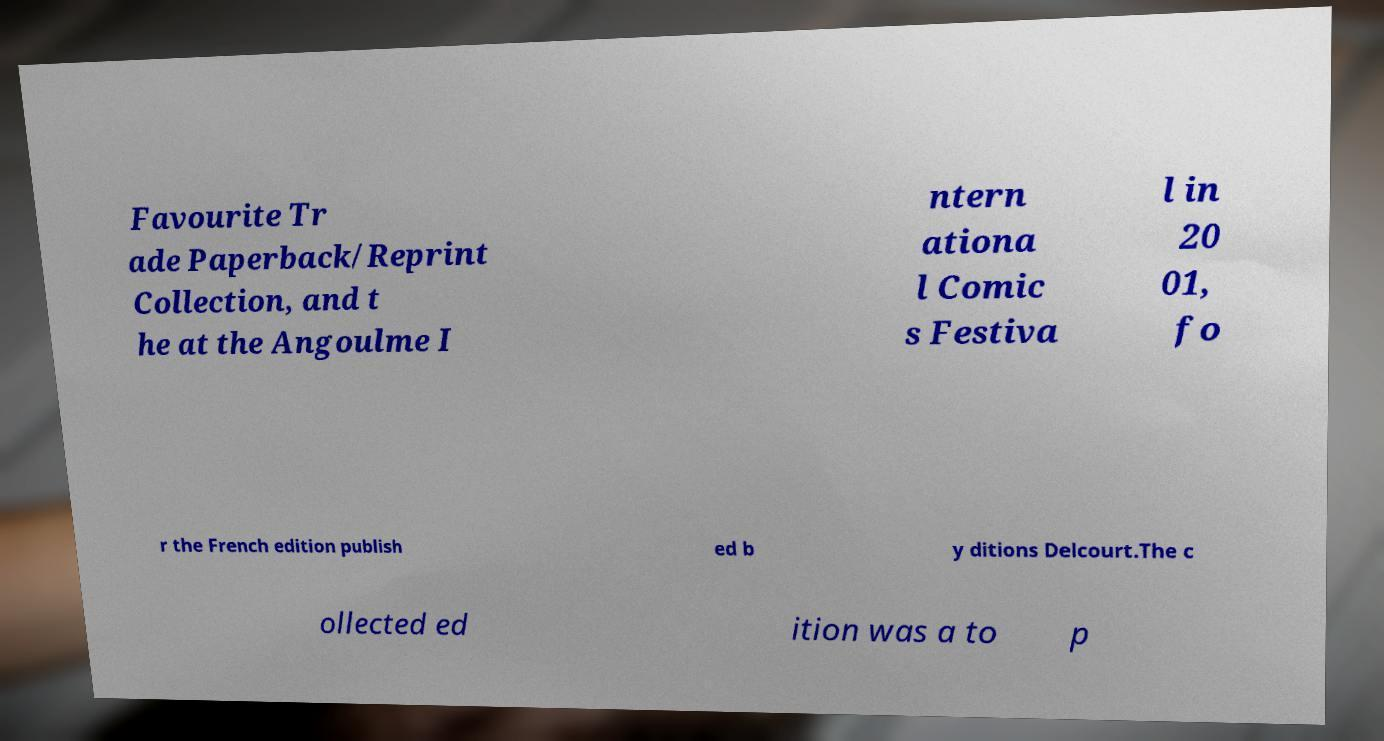There's text embedded in this image that I need extracted. Can you transcribe it verbatim? Favourite Tr ade Paperback/Reprint Collection, and t he at the Angoulme I ntern ationa l Comic s Festiva l in 20 01, fo r the French edition publish ed b y ditions Delcourt.The c ollected ed ition was a to p 